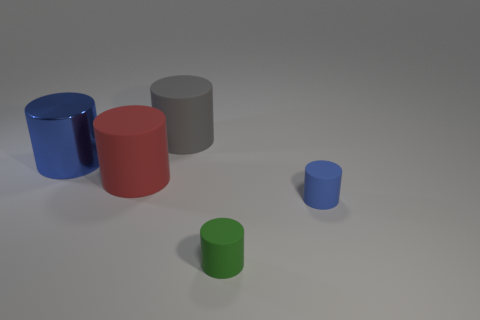Subtract all gray cylinders. How many cylinders are left? 4 Subtract all large gray cylinders. How many cylinders are left? 4 Subtract all cyan cylinders. Subtract all cyan blocks. How many cylinders are left? 5 Add 2 big red spheres. How many objects exist? 7 Subtract all tiny things. Subtract all big gray metallic cylinders. How many objects are left? 3 Add 3 tiny green things. How many tiny green things are left? 4 Add 4 big things. How many big things exist? 7 Subtract 0 blue balls. How many objects are left? 5 